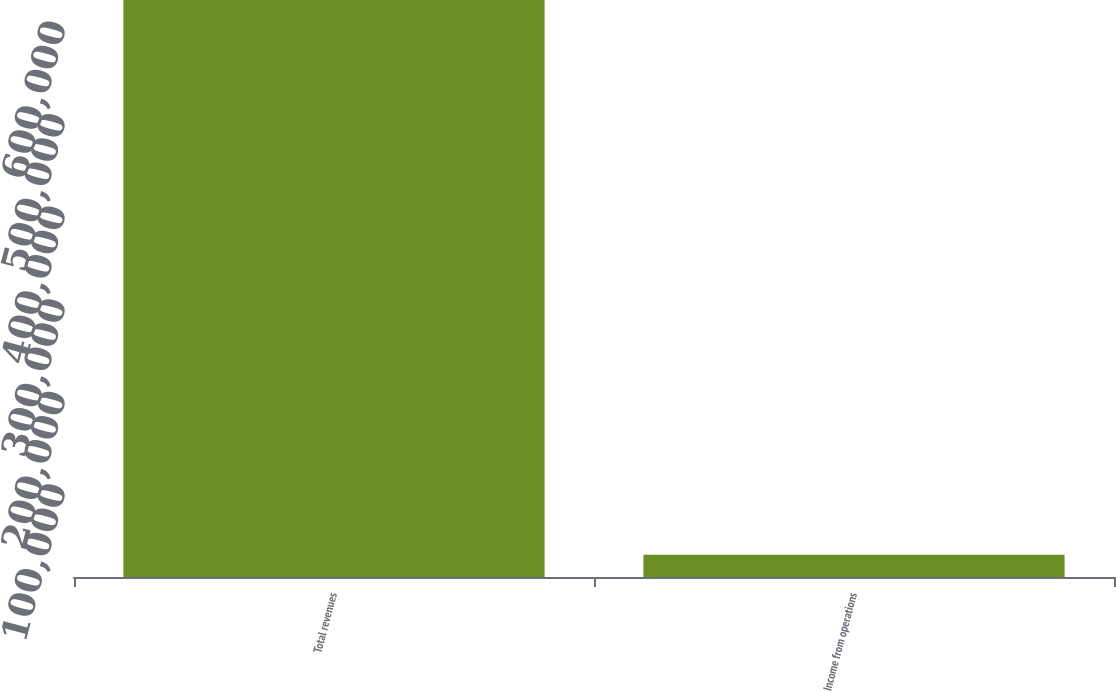<chart> <loc_0><loc_0><loc_500><loc_500><bar_chart><fcel>Total revenues<fcel>Income from operations<nl><fcel>623245<fcel>24131<nl></chart> 